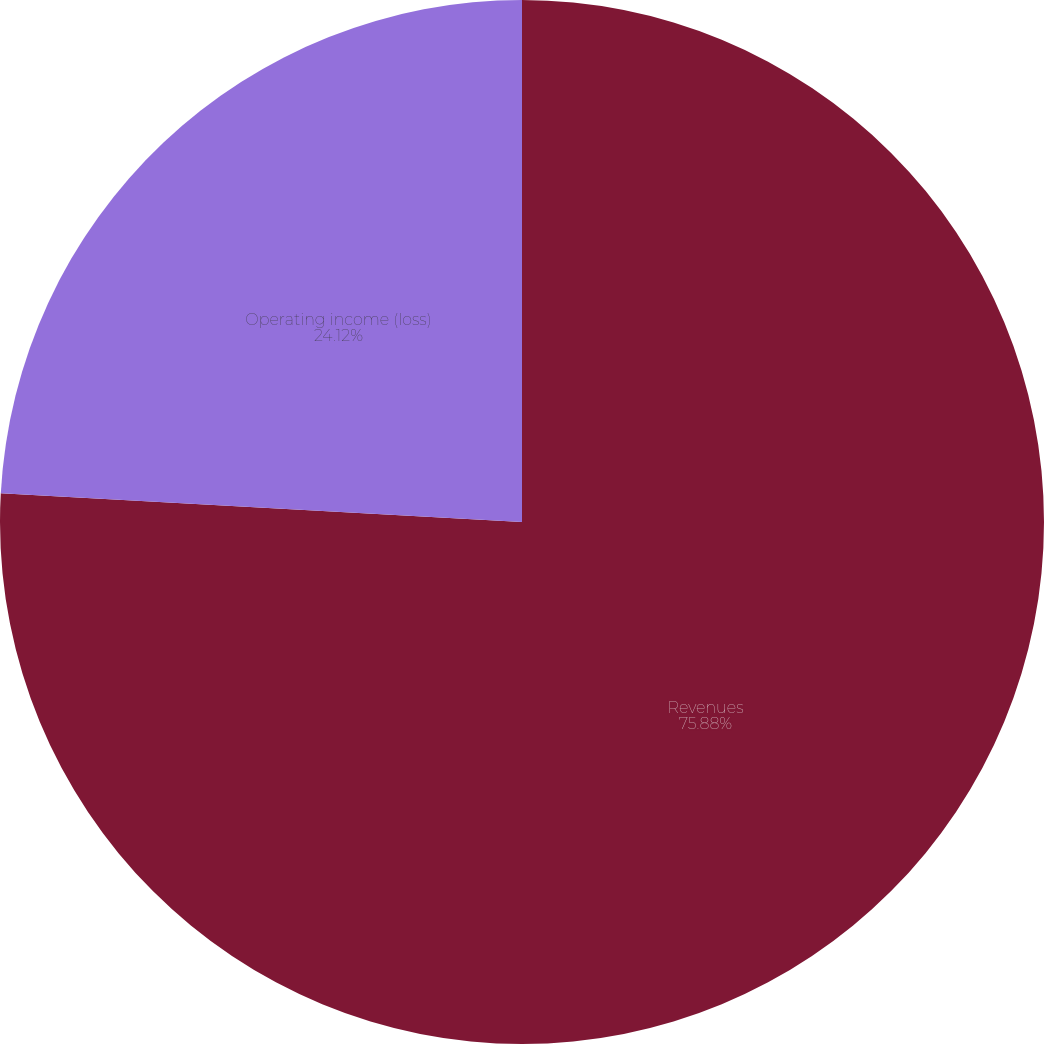Convert chart to OTSL. <chart><loc_0><loc_0><loc_500><loc_500><pie_chart><fcel>Revenues<fcel>Operating income (loss)<nl><fcel>75.88%<fcel>24.12%<nl></chart> 